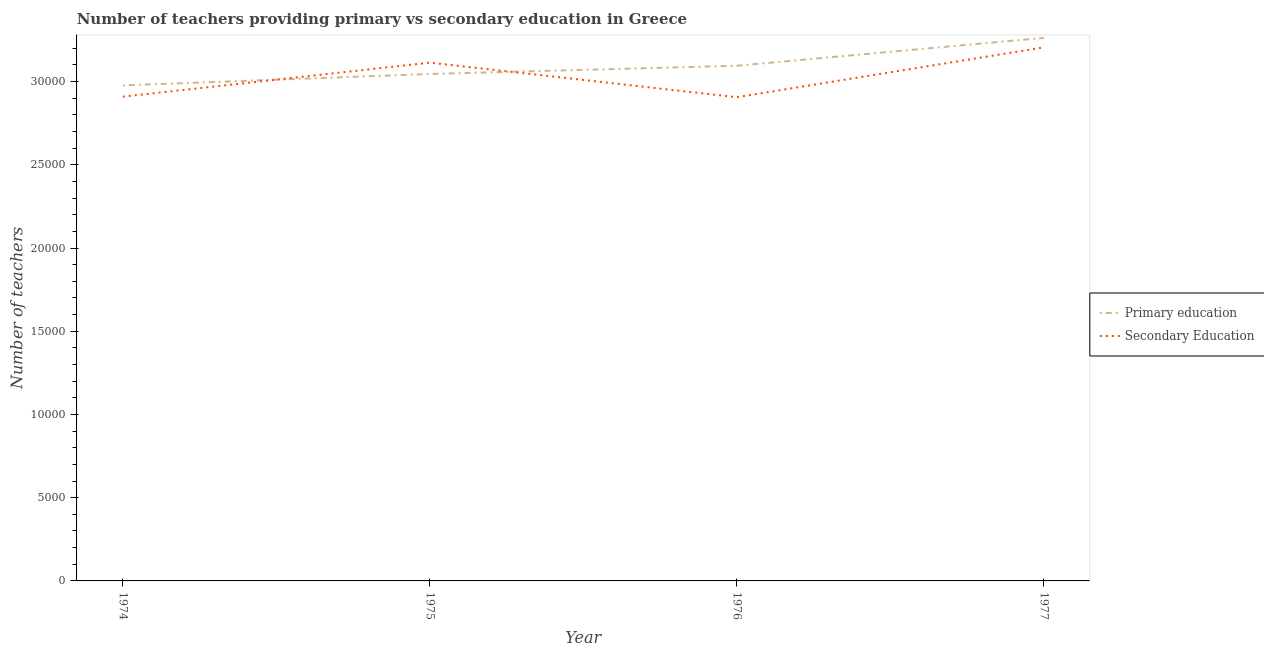How many different coloured lines are there?
Your answer should be compact. 2. Does the line corresponding to number of primary teachers intersect with the line corresponding to number of secondary teachers?
Your answer should be very brief. Yes. Is the number of lines equal to the number of legend labels?
Give a very brief answer. Yes. What is the number of primary teachers in 1977?
Ensure brevity in your answer.  3.26e+04. Across all years, what is the maximum number of secondary teachers?
Offer a very short reply. 3.21e+04. Across all years, what is the minimum number of primary teachers?
Offer a very short reply. 2.98e+04. In which year was the number of primary teachers maximum?
Ensure brevity in your answer.  1977. In which year was the number of primary teachers minimum?
Offer a very short reply. 1974. What is the total number of primary teachers in the graph?
Give a very brief answer. 1.24e+05. What is the difference between the number of secondary teachers in 1975 and that in 1976?
Your response must be concise. 2077. What is the difference between the number of secondary teachers in 1977 and the number of primary teachers in 1976?
Make the answer very short. 1104. What is the average number of secondary teachers per year?
Keep it short and to the point. 3.03e+04. In the year 1976, what is the difference between the number of secondary teachers and number of primary teachers?
Provide a short and direct response. -1891. In how many years, is the number of primary teachers greater than 7000?
Give a very brief answer. 4. What is the ratio of the number of secondary teachers in 1976 to that in 1977?
Your answer should be compact. 0.91. What is the difference between the highest and the second highest number of secondary teachers?
Your response must be concise. 918. What is the difference between the highest and the lowest number of secondary teachers?
Give a very brief answer. 2995. In how many years, is the number of secondary teachers greater than the average number of secondary teachers taken over all years?
Your answer should be compact. 2. Does the number of secondary teachers monotonically increase over the years?
Your response must be concise. No. Is the number of secondary teachers strictly less than the number of primary teachers over the years?
Your response must be concise. No. How many lines are there?
Your answer should be compact. 2. How many years are there in the graph?
Your answer should be very brief. 4. What is the difference between two consecutive major ticks on the Y-axis?
Your answer should be very brief. 5000. Are the values on the major ticks of Y-axis written in scientific E-notation?
Give a very brief answer. No. Where does the legend appear in the graph?
Your answer should be very brief. Center right. How are the legend labels stacked?
Make the answer very short. Vertical. What is the title of the graph?
Your response must be concise. Number of teachers providing primary vs secondary education in Greece. Does "Unregistered firms" appear as one of the legend labels in the graph?
Make the answer very short. No. What is the label or title of the Y-axis?
Provide a short and direct response. Number of teachers. What is the Number of teachers of Primary education in 1974?
Offer a terse response. 2.98e+04. What is the Number of teachers in Secondary Education in 1974?
Provide a short and direct response. 2.91e+04. What is the Number of teachers in Primary education in 1975?
Give a very brief answer. 3.05e+04. What is the Number of teachers of Secondary Education in 1975?
Give a very brief answer. 3.11e+04. What is the Number of teachers in Primary education in 1976?
Provide a succinct answer. 3.10e+04. What is the Number of teachers in Secondary Education in 1976?
Make the answer very short. 2.91e+04. What is the Number of teachers in Primary education in 1977?
Ensure brevity in your answer.  3.26e+04. What is the Number of teachers in Secondary Education in 1977?
Keep it short and to the point. 3.21e+04. Across all years, what is the maximum Number of teachers of Primary education?
Provide a succinct answer. 3.26e+04. Across all years, what is the maximum Number of teachers of Secondary Education?
Provide a succinct answer. 3.21e+04. Across all years, what is the minimum Number of teachers of Primary education?
Make the answer very short. 2.98e+04. Across all years, what is the minimum Number of teachers of Secondary Education?
Offer a terse response. 2.91e+04. What is the total Number of teachers of Primary education in the graph?
Provide a short and direct response. 1.24e+05. What is the total Number of teachers of Secondary Education in the graph?
Your answer should be compact. 1.21e+05. What is the difference between the Number of teachers of Primary education in 1974 and that in 1975?
Your answer should be very brief. -685. What is the difference between the Number of teachers of Secondary Education in 1974 and that in 1975?
Offer a very short reply. -2044. What is the difference between the Number of teachers in Primary education in 1974 and that in 1976?
Your answer should be very brief. -1180. What is the difference between the Number of teachers of Secondary Education in 1974 and that in 1976?
Offer a terse response. 33. What is the difference between the Number of teachers of Primary education in 1974 and that in 1977?
Ensure brevity in your answer.  -2856. What is the difference between the Number of teachers in Secondary Education in 1974 and that in 1977?
Provide a succinct answer. -2962. What is the difference between the Number of teachers in Primary education in 1975 and that in 1976?
Provide a succinct answer. -495. What is the difference between the Number of teachers of Secondary Education in 1975 and that in 1976?
Your answer should be very brief. 2077. What is the difference between the Number of teachers of Primary education in 1975 and that in 1977?
Your answer should be compact. -2171. What is the difference between the Number of teachers in Secondary Education in 1975 and that in 1977?
Ensure brevity in your answer.  -918. What is the difference between the Number of teachers of Primary education in 1976 and that in 1977?
Give a very brief answer. -1676. What is the difference between the Number of teachers in Secondary Education in 1976 and that in 1977?
Ensure brevity in your answer.  -2995. What is the difference between the Number of teachers in Primary education in 1974 and the Number of teachers in Secondary Education in 1975?
Provide a succinct answer. -1366. What is the difference between the Number of teachers of Primary education in 1974 and the Number of teachers of Secondary Education in 1976?
Offer a terse response. 711. What is the difference between the Number of teachers in Primary education in 1974 and the Number of teachers in Secondary Education in 1977?
Your answer should be compact. -2284. What is the difference between the Number of teachers in Primary education in 1975 and the Number of teachers in Secondary Education in 1976?
Provide a short and direct response. 1396. What is the difference between the Number of teachers of Primary education in 1975 and the Number of teachers of Secondary Education in 1977?
Provide a succinct answer. -1599. What is the difference between the Number of teachers of Primary education in 1976 and the Number of teachers of Secondary Education in 1977?
Ensure brevity in your answer.  -1104. What is the average Number of teachers of Primary education per year?
Provide a succinct answer. 3.10e+04. What is the average Number of teachers of Secondary Education per year?
Offer a terse response. 3.03e+04. In the year 1974, what is the difference between the Number of teachers of Primary education and Number of teachers of Secondary Education?
Your response must be concise. 678. In the year 1975, what is the difference between the Number of teachers of Primary education and Number of teachers of Secondary Education?
Provide a succinct answer. -681. In the year 1976, what is the difference between the Number of teachers in Primary education and Number of teachers in Secondary Education?
Your response must be concise. 1891. In the year 1977, what is the difference between the Number of teachers in Primary education and Number of teachers in Secondary Education?
Make the answer very short. 572. What is the ratio of the Number of teachers of Primary education in 1974 to that in 1975?
Provide a succinct answer. 0.98. What is the ratio of the Number of teachers of Secondary Education in 1974 to that in 1975?
Your answer should be very brief. 0.93. What is the ratio of the Number of teachers in Primary education in 1974 to that in 1976?
Offer a very short reply. 0.96. What is the ratio of the Number of teachers in Secondary Education in 1974 to that in 1976?
Ensure brevity in your answer.  1. What is the ratio of the Number of teachers in Primary education in 1974 to that in 1977?
Offer a very short reply. 0.91. What is the ratio of the Number of teachers of Secondary Education in 1974 to that in 1977?
Provide a succinct answer. 0.91. What is the ratio of the Number of teachers in Secondary Education in 1975 to that in 1976?
Offer a terse response. 1.07. What is the ratio of the Number of teachers in Primary education in 1975 to that in 1977?
Your answer should be very brief. 0.93. What is the ratio of the Number of teachers of Secondary Education in 1975 to that in 1977?
Your answer should be compact. 0.97. What is the ratio of the Number of teachers in Primary education in 1976 to that in 1977?
Your answer should be compact. 0.95. What is the ratio of the Number of teachers of Secondary Education in 1976 to that in 1977?
Keep it short and to the point. 0.91. What is the difference between the highest and the second highest Number of teachers of Primary education?
Keep it short and to the point. 1676. What is the difference between the highest and the second highest Number of teachers in Secondary Education?
Offer a terse response. 918. What is the difference between the highest and the lowest Number of teachers of Primary education?
Provide a short and direct response. 2856. What is the difference between the highest and the lowest Number of teachers of Secondary Education?
Your answer should be very brief. 2995. 